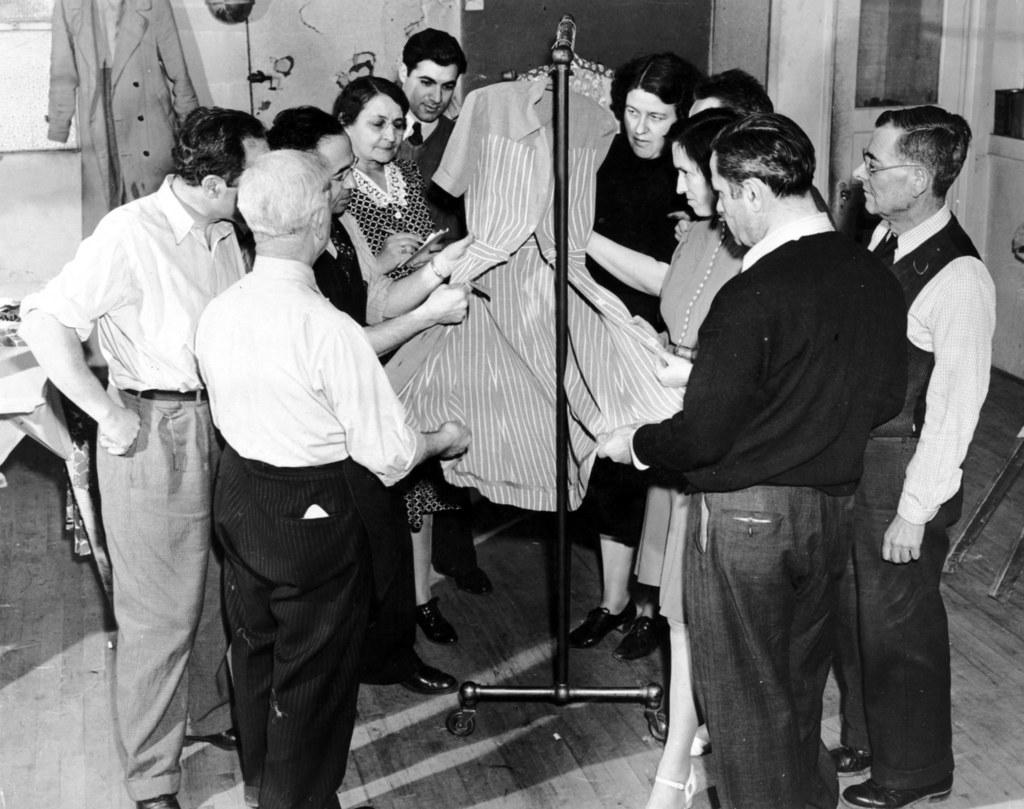What are the people in the image doing? The people in the image are standing in the center. What can be seen in the image besides the people? There is a stand and clothes placed on a hanger in the image. What is visible in the background of the image? There is a wall and a coat visible in the background of the image. What type of prose is being read by the people in the image? There is no indication in the image that the people are reading any prose, as the focus is on their standing positions and the surrounding objects. 